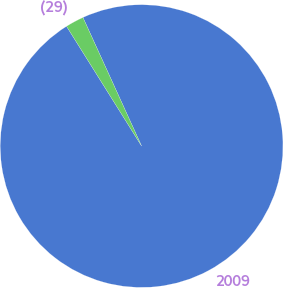Convert chart to OTSL. <chart><loc_0><loc_0><loc_500><loc_500><pie_chart><fcel>2009<fcel>(29)<nl><fcel>97.9%<fcel>2.1%<nl></chart> 